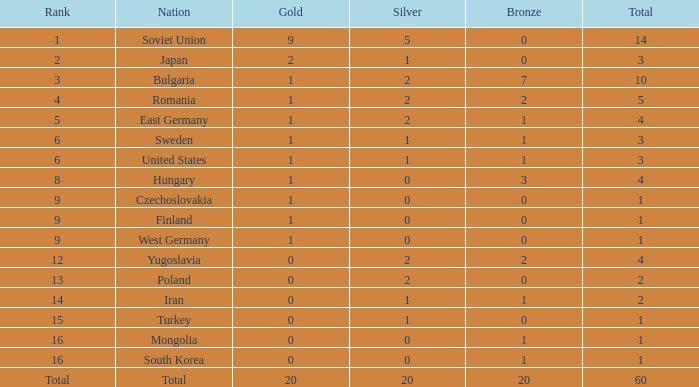How many cases have fewer than 2 silvers, at least 1 bronze, and over 1 gold? 0.0. 